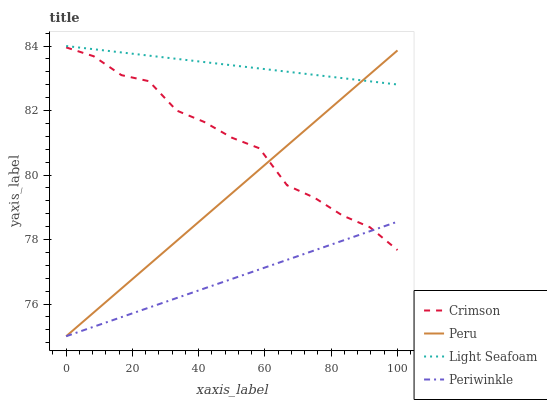Does Periwinkle have the minimum area under the curve?
Answer yes or no. Yes. Does Light Seafoam have the maximum area under the curve?
Answer yes or no. Yes. Does Light Seafoam have the minimum area under the curve?
Answer yes or no. No. Does Periwinkle have the maximum area under the curve?
Answer yes or no. No. Is Periwinkle the smoothest?
Answer yes or no. Yes. Is Crimson the roughest?
Answer yes or no. Yes. Is Light Seafoam the smoothest?
Answer yes or no. No. Is Light Seafoam the roughest?
Answer yes or no. No. Does Light Seafoam have the lowest value?
Answer yes or no. No. Does Light Seafoam have the highest value?
Answer yes or no. Yes. Does Periwinkle have the highest value?
Answer yes or no. No. Is Periwinkle less than Light Seafoam?
Answer yes or no. Yes. Is Light Seafoam greater than Crimson?
Answer yes or no. Yes. Does Peru intersect Light Seafoam?
Answer yes or no. Yes. Is Peru less than Light Seafoam?
Answer yes or no. No. Is Peru greater than Light Seafoam?
Answer yes or no. No. Does Periwinkle intersect Light Seafoam?
Answer yes or no. No. 